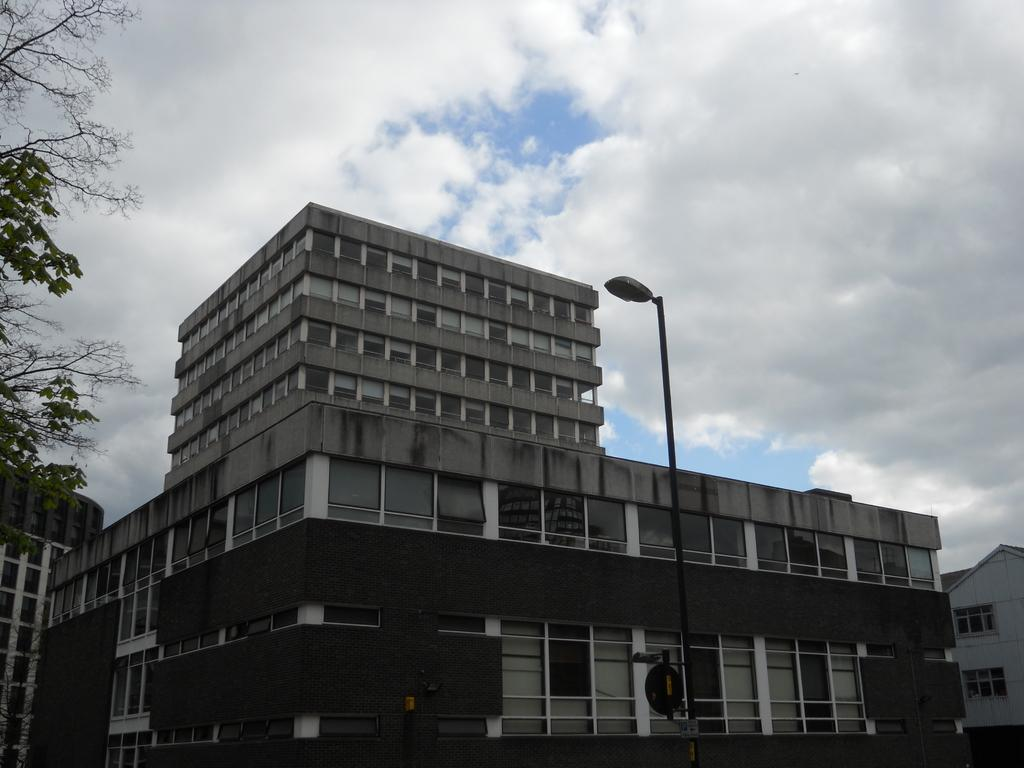What type of structures can be seen in the image? There are buildings in the image. What other natural elements are present in the image? There are trees in the image. How would you describe the weather based on the image? The sky is cloudy in the image, suggesting a potentially overcast or cloudy day. What type of sofa can be seen in the image? There is no sofa present in the image. How does the war affect the buildings in the image? There is no war present in the image, so its effects cannot be determined. 